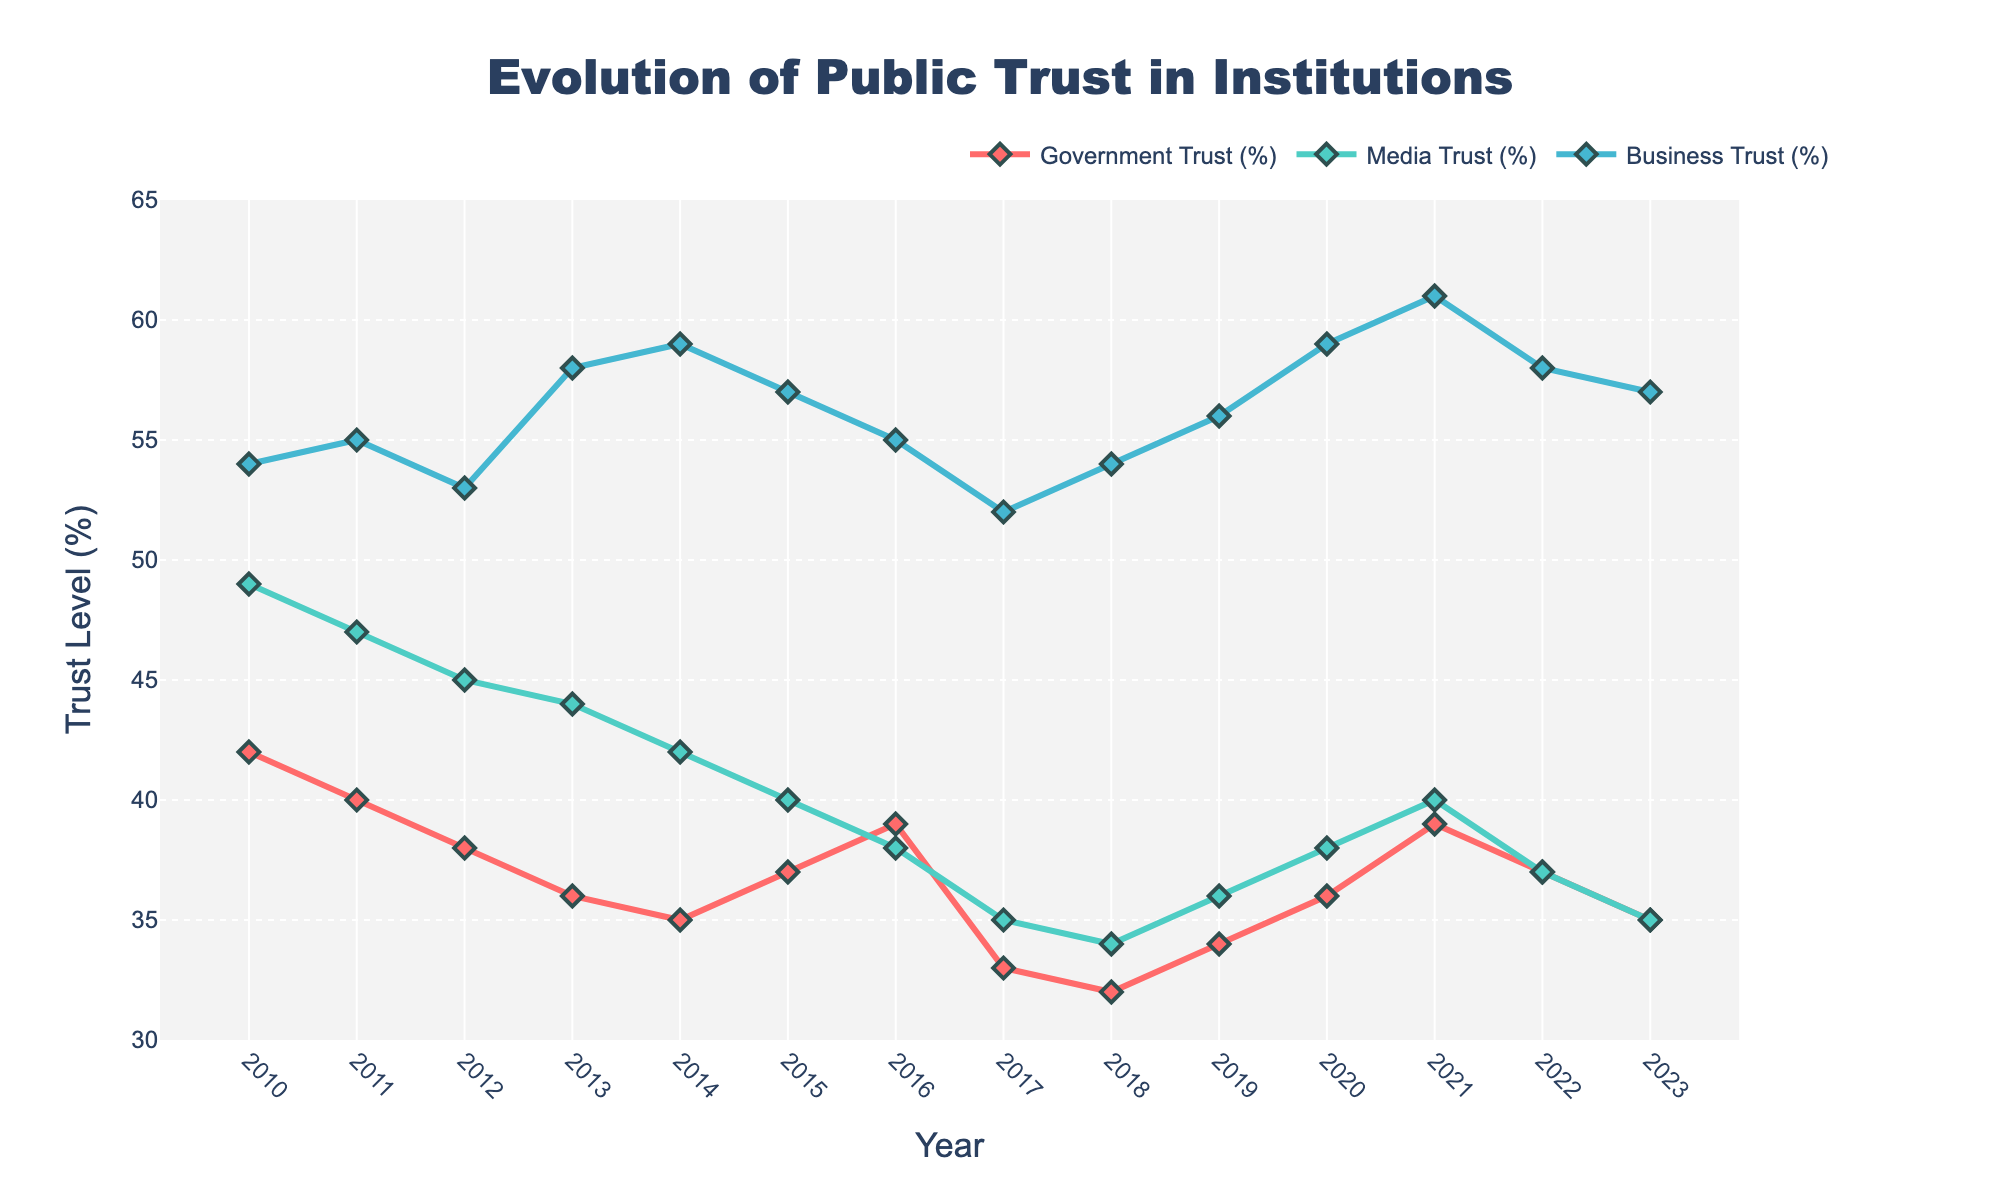What's the trend in public trust in government over the years? The line chart shows the public trust in government starting from 42% in 2010 and generally decreasing each year to 33% in 2017, followed by a small increase to 39% in 2021, and then a decline again to 35% in 2023.
Answer: Generally decreasing Which institution had the highest trust level in 2023? According to the chart, in 2023, the trust levels were 35% for government, 35% for media, and 57% for businesses. Therefore, businesses had the highest trust level.
Answer: Businesses What was the largest decrease in trust for any institution within a one-year period? Examining the lines, the largest single-year drop is for government trust between 2016 and 2017, where it fell from 39% to 33%, a decrease of 6%.
Answer: 6% How does the media's trust level in 2010 compare to its level in 2020? In 2010, media trust was at 49%, while in 2020 it was 38%.
Answer: Lower in 2020 Which year's data shows the smallest gap between the trust levels of government and business? Check the gaps year by year; the smallest gap is in 2014, where government trust was 35% and business trust was 59%, a gap of 24%.
Answer: 2014 What is the overall trend in public trust in businesses from 2010 to 2023? The chart shows that trust in businesses increased from 54% in 2010 to a peak of 61% in 2021 and then slightly decreased to 57% in 2023.
Answer: Increasing with minor recent decrease Is there any year where all three institutions had the same trust level? Scan through the entire chart; in 2023, both government and media had 35%, but no year sees all three institutions with the same trust level.
Answer: No How many times did the government trust level show an increase from one year to the next? Look for upward movements in the government trust line, which happened in 2015, 2016, 2019, and 2021. That's 4 times.
Answer: 4 What can be inferred about the relationship between media and business trust levels over the years? Media trust generally declined from 49% to 35%, while business trust showed a general increase. These trends suggest that public trust in these areas moved in opposite directions more often than not.
Answer: Opposite directions Which year had the highest trust level for any institution and what was it? The highest observed trust level is for businesses in 2021, at 61%.
Answer: 2021, 61% 